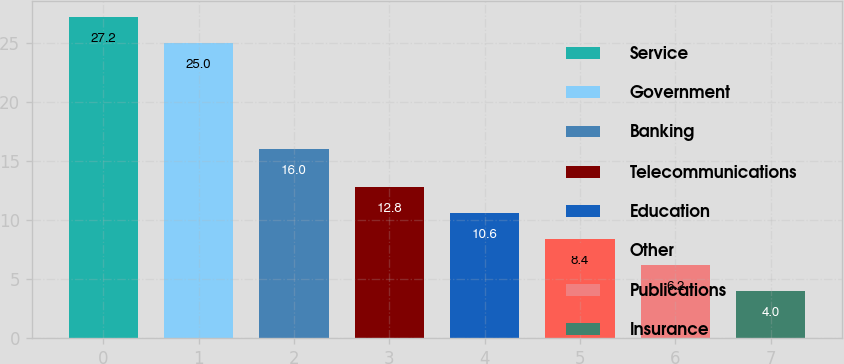Convert chart. <chart><loc_0><loc_0><loc_500><loc_500><bar_chart><fcel>Service<fcel>Government<fcel>Banking<fcel>Telecommunications<fcel>Education<fcel>Other<fcel>Publications<fcel>Insurance<nl><fcel>27.2<fcel>25<fcel>16<fcel>12.8<fcel>10.6<fcel>8.4<fcel>6.2<fcel>4<nl></chart> 